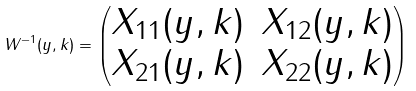Convert formula to latex. <formula><loc_0><loc_0><loc_500><loc_500>W ^ { - 1 } ( y , k ) = \begin{pmatrix} X _ { 1 1 } ( y , k ) & X _ { 1 2 } ( y , k ) \\ X _ { 2 1 } ( y , k ) & X _ { 2 2 } ( y , k ) \end{pmatrix}</formula> 